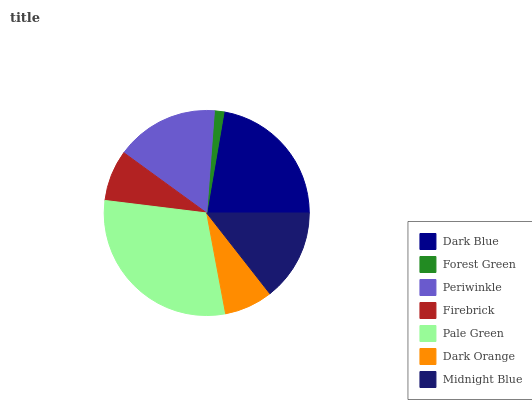Is Forest Green the minimum?
Answer yes or no. Yes. Is Pale Green the maximum?
Answer yes or no. Yes. Is Periwinkle the minimum?
Answer yes or no. No. Is Periwinkle the maximum?
Answer yes or no. No. Is Periwinkle greater than Forest Green?
Answer yes or no. Yes. Is Forest Green less than Periwinkle?
Answer yes or no. Yes. Is Forest Green greater than Periwinkle?
Answer yes or no. No. Is Periwinkle less than Forest Green?
Answer yes or no. No. Is Midnight Blue the high median?
Answer yes or no. Yes. Is Midnight Blue the low median?
Answer yes or no. Yes. Is Periwinkle the high median?
Answer yes or no. No. Is Dark Orange the low median?
Answer yes or no. No. 